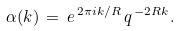<formula> <loc_0><loc_0><loc_500><loc_500>\alpha ( k ) \, = \, e ^ { \, 2 \pi i k / R } \, q ^ { \, - 2 R k } .</formula> 